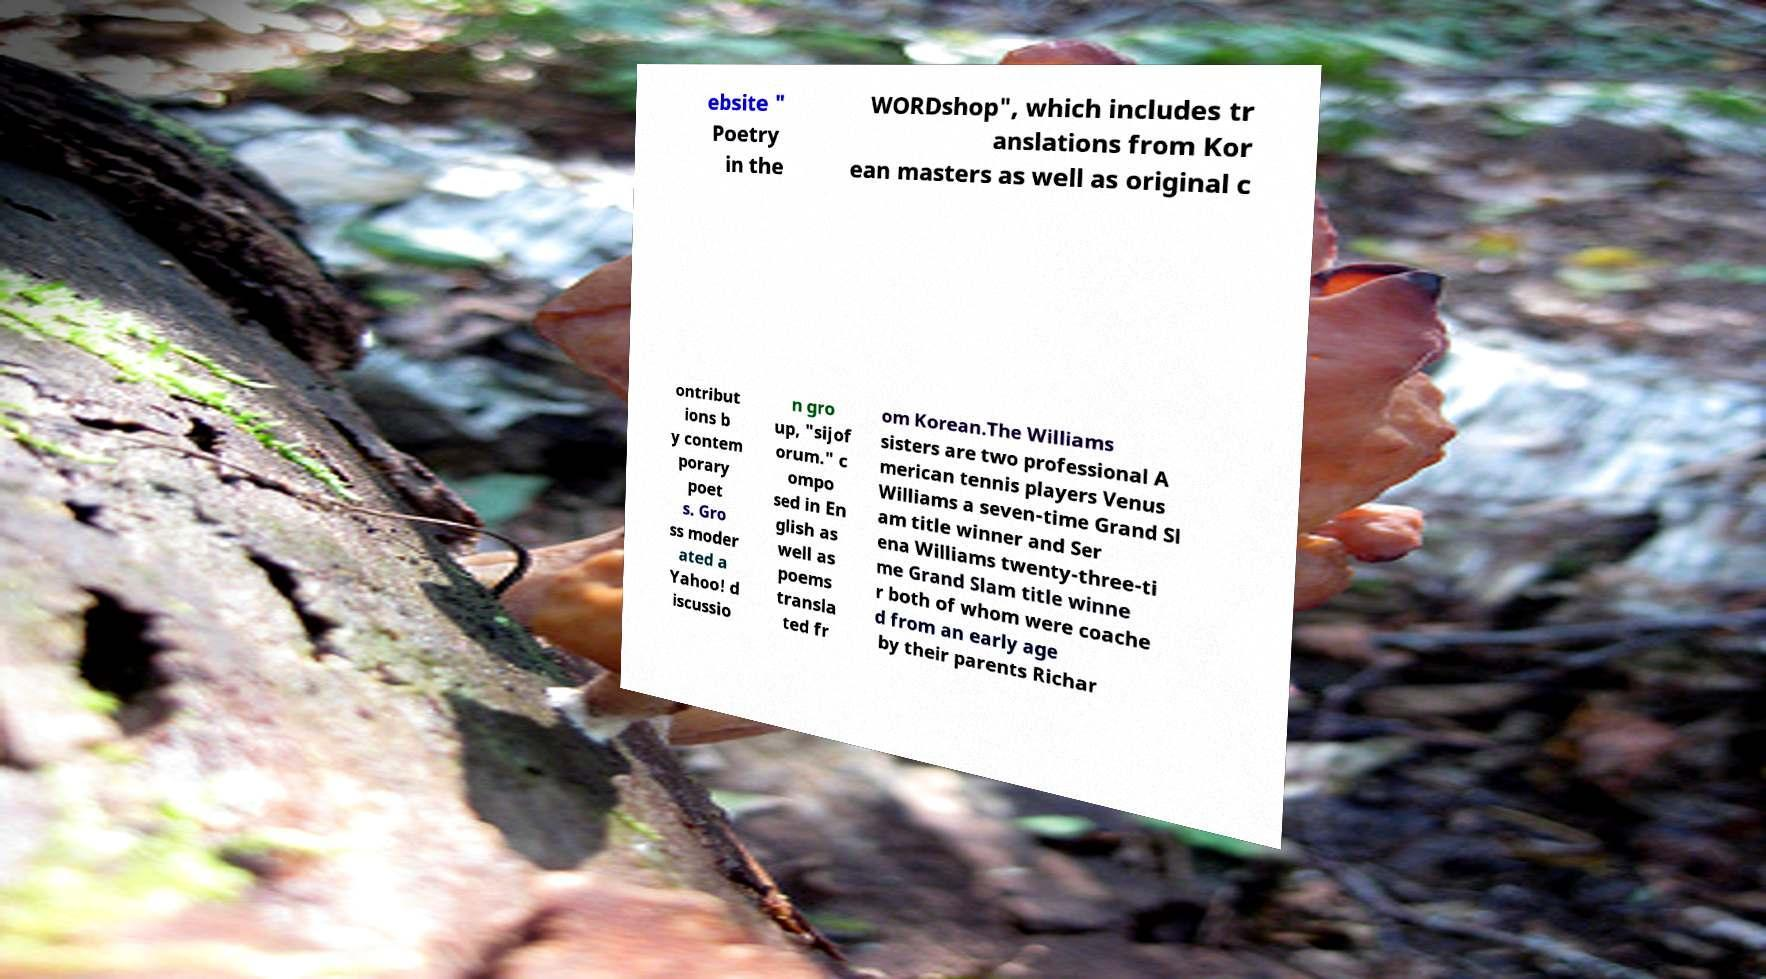Can you accurately transcribe the text from the provided image for me? ebsite " Poetry in the WORDshop", which includes tr anslations from Kor ean masters as well as original c ontribut ions b y contem porary poet s. Gro ss moder ated a Yahoo! d iscussio n gro up, "sijof orum." c ompo sed in En glish as well as poems transla ted fr om Korean.The Williams sisters are two professional A merican tennis players Venus Williams a seven-time Grand Sl am title winner and Ser ena Williams twenty-three-ti me Grand Slam title winne r both of whom were coache d from an early age by their parents Richar 